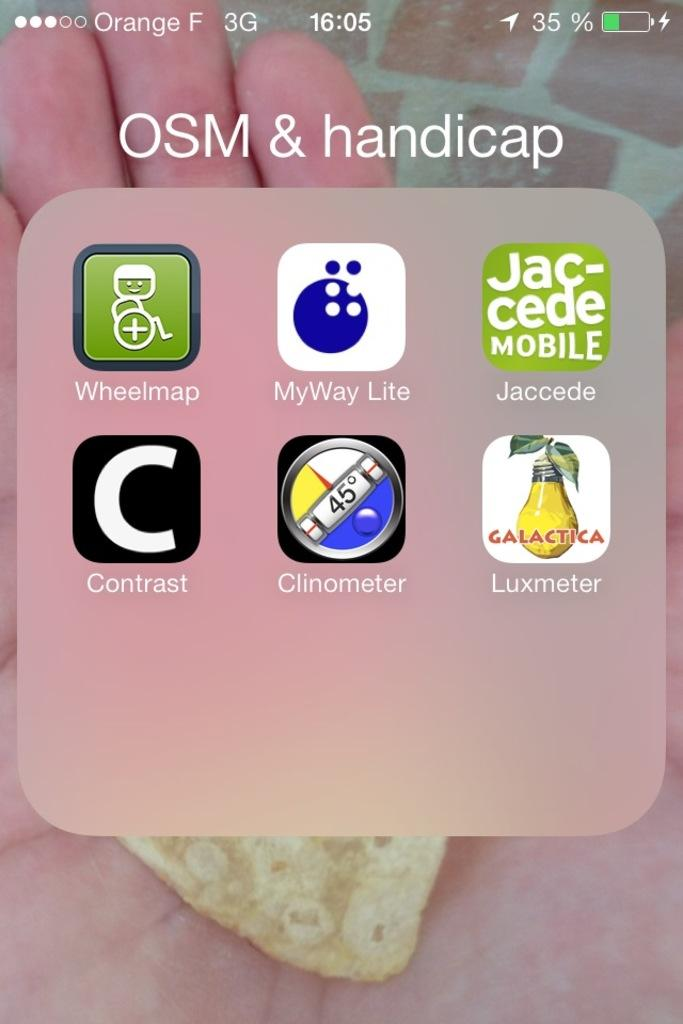<image>
Write a terse but informative summary of the picture. A screen display shows the apps MyWay Lite and Wheelmap on the screen 